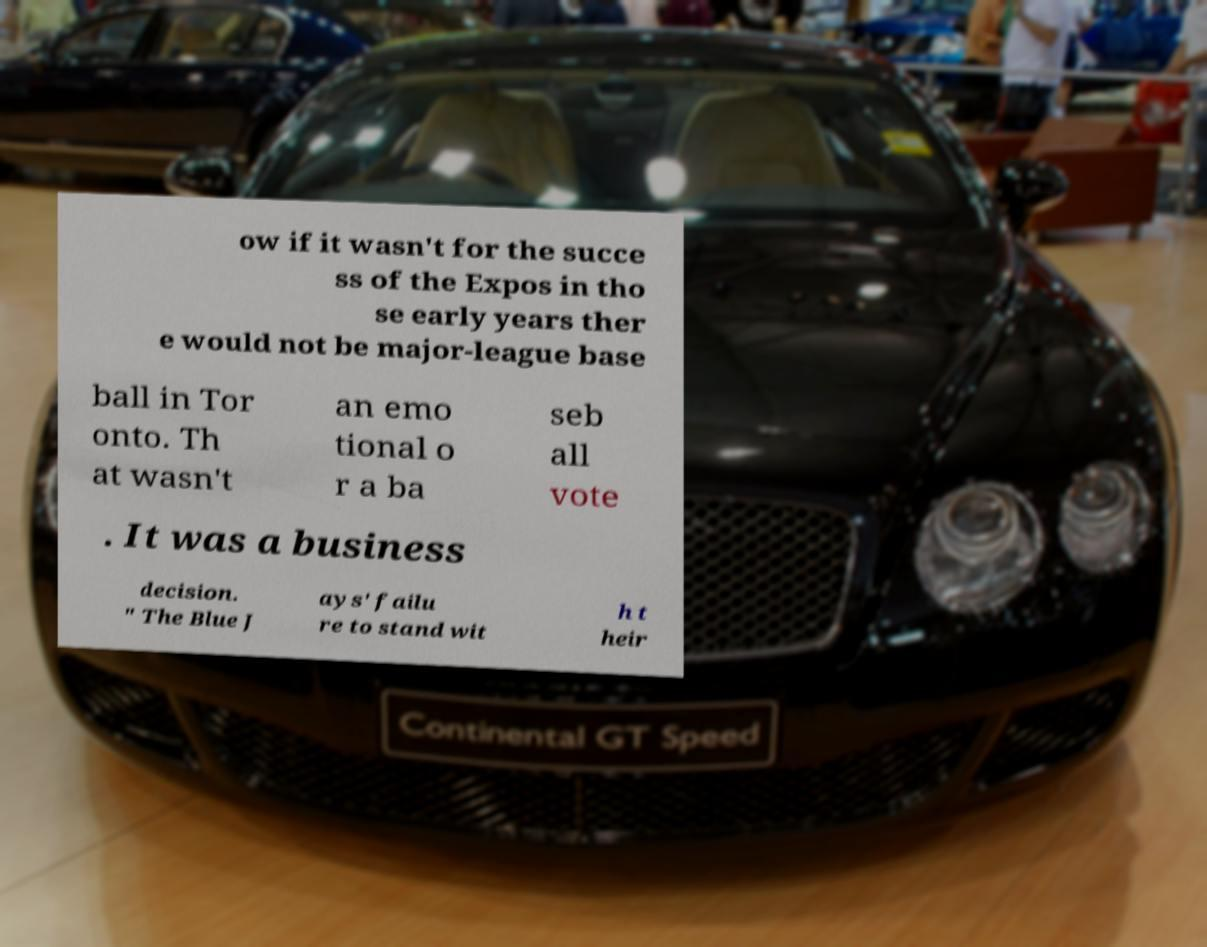There's text embedded in this image that I need extracted. Can you transcribe it verbatim? ow if it wasn't for the succe ss of the Expos in tho se early years ther e would not be major-league base ball in Tor onto. Th at wasn't an emo tional o r a ba seb all vote . It was a business decision. " The Blue J ays' failu re to stand wit h t heir 